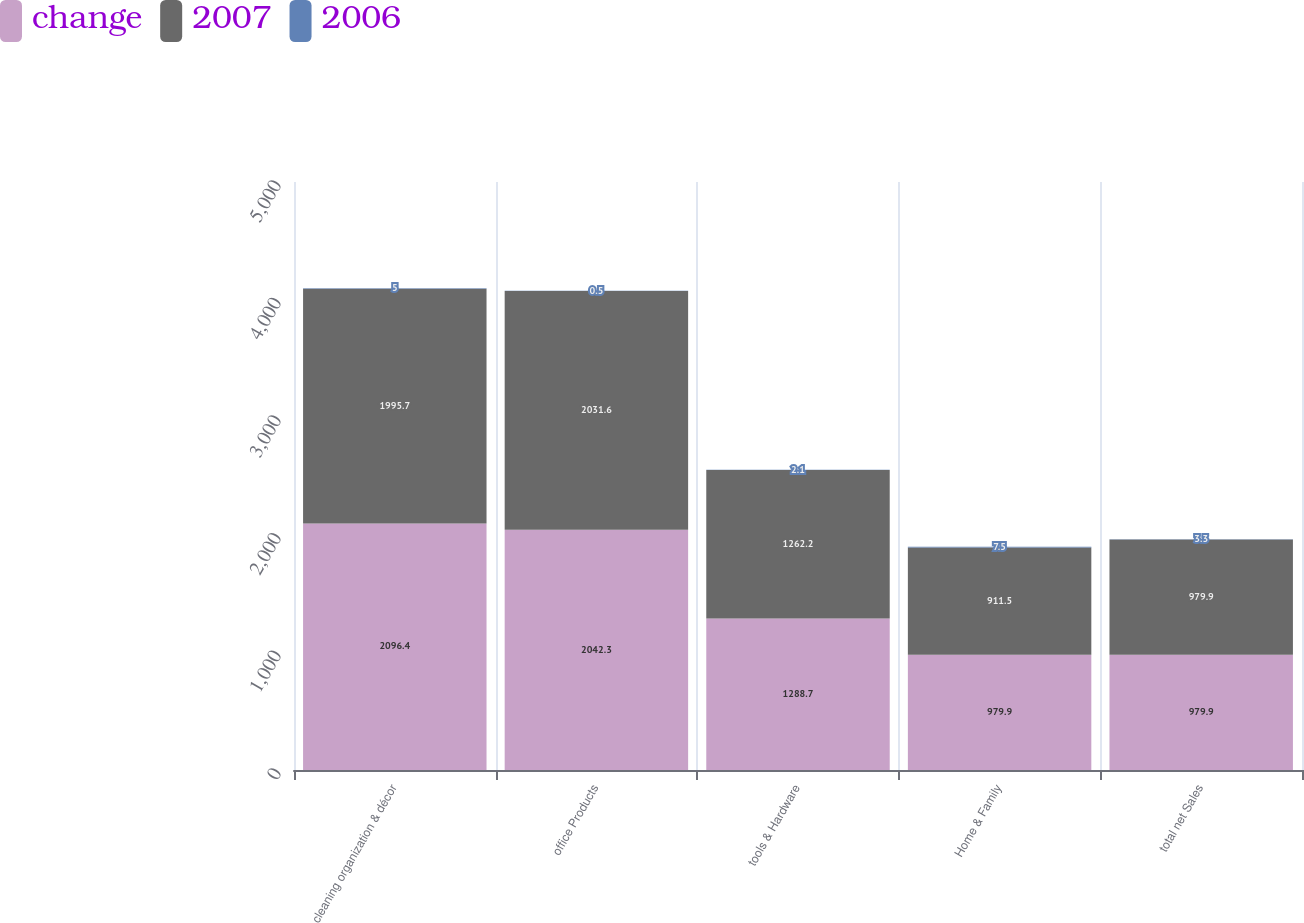<chart> <loc_0><loc_0><loc_500><loc_500><stacked_bar_chart><ecel><fcel>cleaning organization & décor<fcel>office Products<fcel>tools & Hardware<fcel>Home & Family<fcel>total net Sales<nl><fcel>change<fcel>2096.4<fcel>2042.3<fcel>1288.7<fcel>979.9<fcel>979.9<nl><fcel>2007<fcel>1995.7<fcel>2031.6<fcel>1262.2<fcel>911.5<fcel>979.9<nl><fcel>2006<fcel>5<fcel>0.5<fcel>2.1<fcel>7.5<fcel>3.3<nl></chart> 